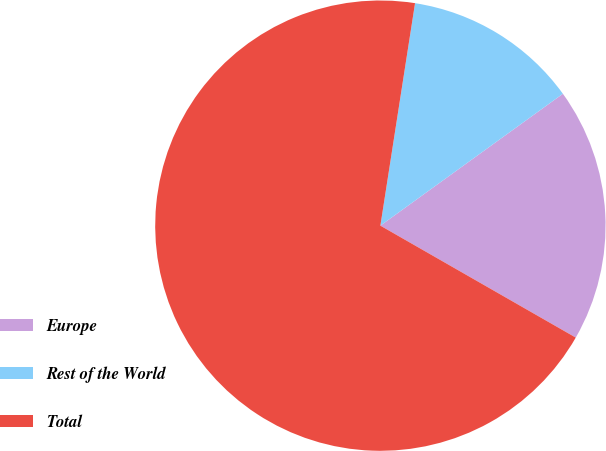Convert chart. <chart><loc_0><loc_0><loc_500><loc_500><pie_chart><fcel>Europe<fcel>Rest of the World<fcel>Total<nl><fcel>18.24%<fcel>12.58%<fcel>69.18%<nl></chart> 